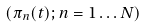Convert formula to latex. <formula><loc_0><loc_0><loc_500><loc_500>( \pi _ { n } ( t ) ; n = 1 \dots N )</formula> 